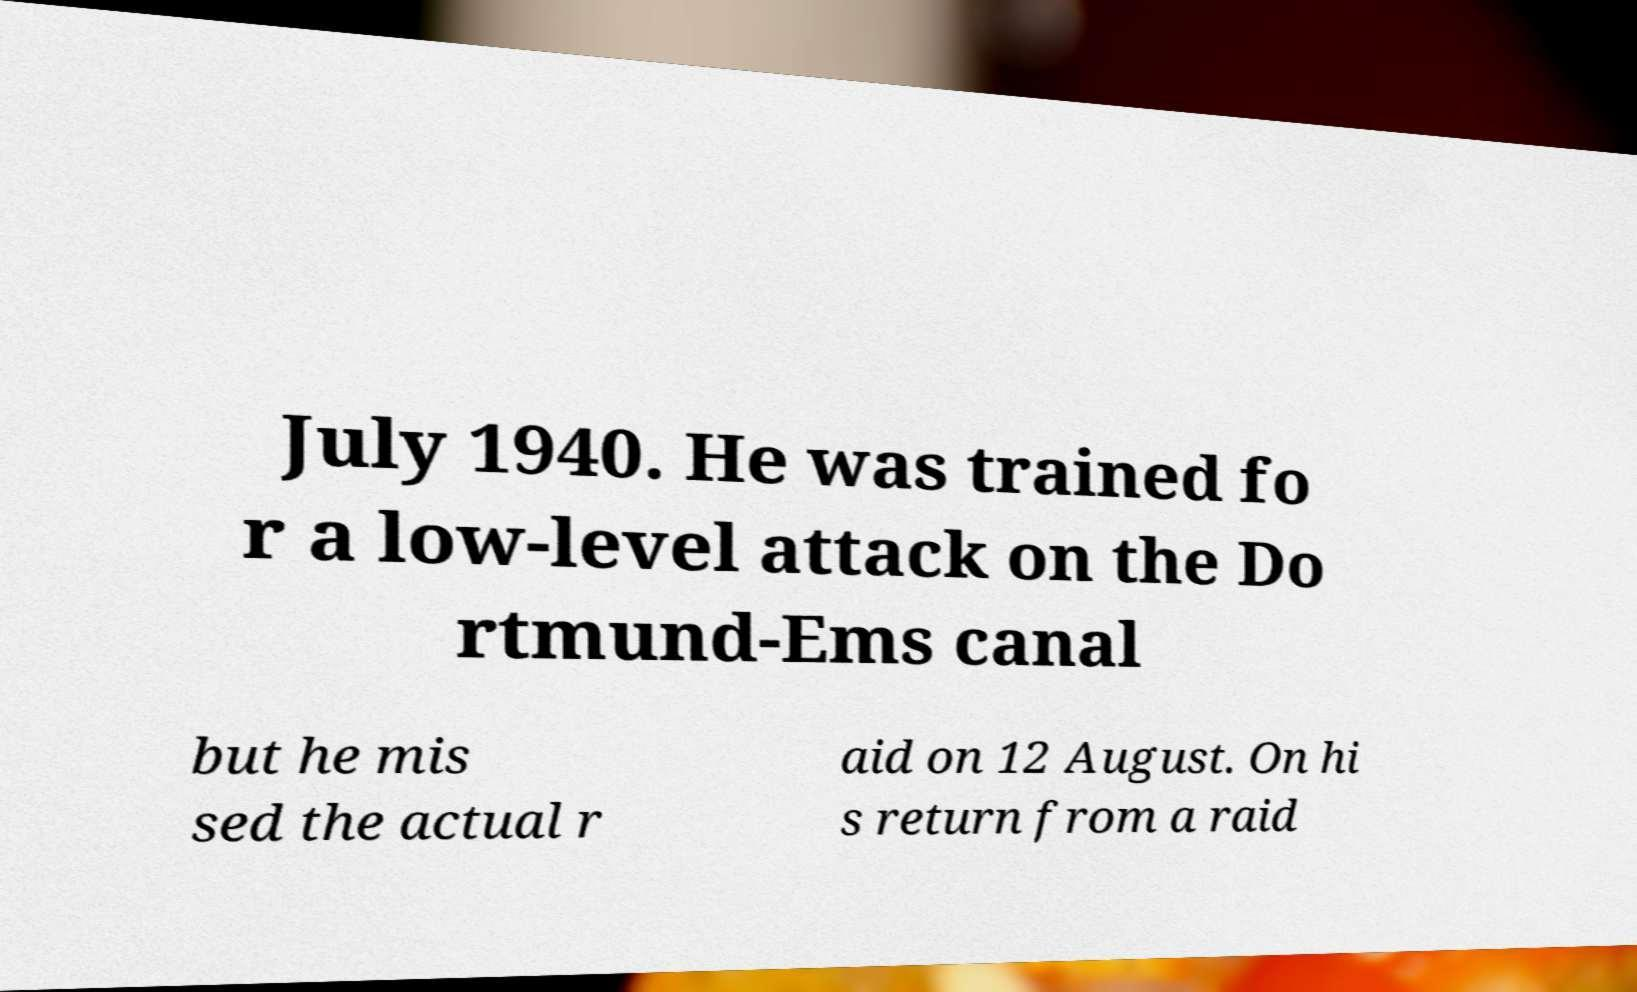What messages or text are displayed in this image? I need them in a readable, typed format. July 1940. He was trained fo r a low-level attack on the Do rtmund-Ems canal but he mis sed the actual r aid on 12 August. On hi s return from a raid 